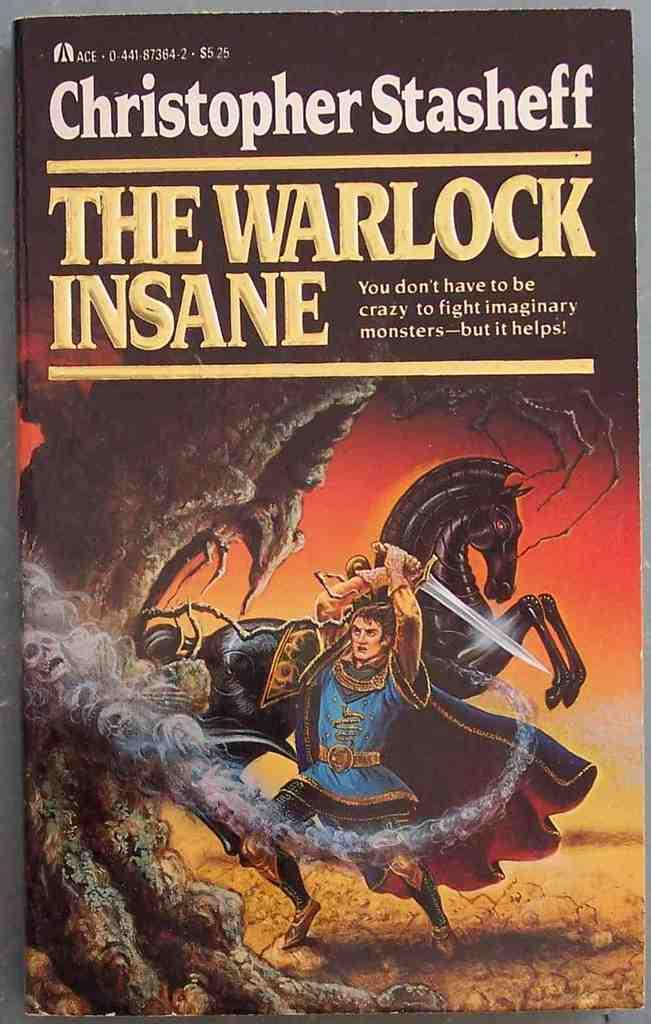<image>
Describe the image concisely. A novel by Christopher Stasheff shows a knight. 